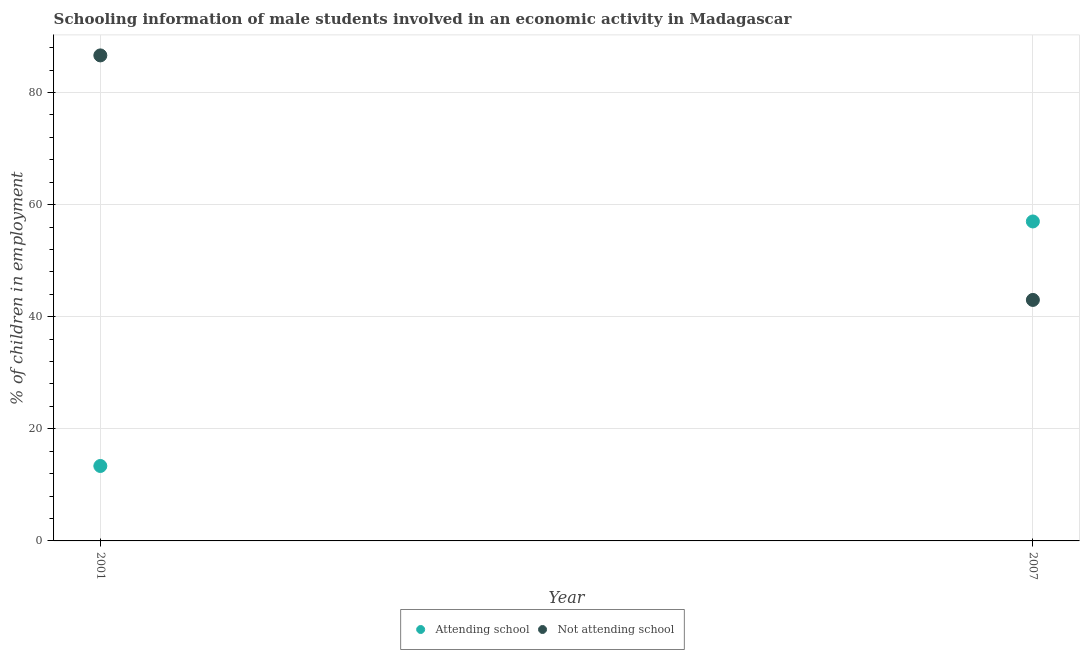What is the percentage of employed males who are not attending school in 2001?
Offer a terse response. 86.63. Across all years, what is the maximum percentage of employed males who are not attending school?
Give a very brief answer. 86.63. In which year was the percentage of employed males who are not attending school maximum?
Provide a short and direct response. 2001. In which year was the percentage of employed males who are attending school minimum?
Offer a very short reply. 2001. What is the total percentage of employed males who are attending school in the graph?
Provide a succinct answer. 70.37. What is the difference between the percentage of employed males who are not attending school in 2001 and that in 2007?
Keep it short and to the point. 43.63. What is the difference between the percentage of employed males who are not attending school in 2007 and the percentage of employed males who are attending school in 2001?
Your response must be concise. 29.63. What is the average percentage of employed males who are attending school per year?
Provide a short and direct response. 35.19. In the year 2001, what is the difference between the percentage of employed males who are attending school and percentage of employed males who are not attending school?
Your answer should be very brief. -73.26. In how many years, is the percentage of employed males who are not attending school greater than 52 %?
Keep it short and to the point. 1. What is the ratio of the percentage of employed males who are attending school in 2001 to that in 2007?
Make the answer very short. 0.23. Does the percentage of employed males who are attending school monotonically increase over the years?
Keep it short and to the point. Yes. Is the percentage of employed males who are attending school strictly less than the percentage of employed males who are not attending school over the years?
Ensure brevity in your answer.  No. How many dotlines are there?
Offer a very short reply. 2. Does the graph contain grids?
Ensure brevity in your answer.  Yes. How are the legend labels stacked?
Your answer should be very brief. Horizontal. What is the title of the graph?
Ensure brevity in your answer.  Schooling information of male students involved in an economic activity in Madagascar. What is the label or title of the X-axis?
Your answer should be very brief. Year. What is the label or title of the Y-axis?
Your answer should be very brief. % of children in employment. What is the % of children in employment in Attending school in 2001?
Provide a succinct answer. 13.37. What is the % of children in employment in Not attending school in 2001?
Keep it short and to the point. 86.63. What is the % of children in employment of Not attending school in 2007?
Ensure brevity in your answer.  43. Across all years, what is the maximum % of children in employment in Not attending school?
Your answer should be compact. 86.63. Across all years, what is the minimum % of children in employment of Attending school?
Offer a terse response. 13.37. What is the total % of children in employment in Attending school in the graph?
Provide a succinct answer. 70.37. What is the total % of children in employment of Not attending school in the graph?
Make the answer very short. 129.63. What is the difference between the % of children in employment in Attending school in 2001 and that in 2007?
Your response must be concise. -43.63. What is the difference between the % of children in employment in Not attending school in 2001 and that in 2007?
Give a very brief answer. 43.63. What is the difference between the % of children in employment in Attending school in 2001 and the % of children in employment in Not attending school in 2007?
Provide a succinct answer. -29.63. What is the average % of children in employment of Attending school per year?
Keep it short and to the point. 35.19. What is the average % of children in employment of Not attending school per year?
Your answer should be compact. 64.81. In the year 2001, what is the difference between the % of children in employment of Attending school and % of children in employment of Not attending school?
Provide a short and direct response. -73.26. What is the ratio of the % of children in employment of Attending school in 2001 to that in 2007?
Provide a short and direct response. 0.23. What is the ratio of the % of children in employment in Not attending school in 2001 to that in 2007?
Give a very brief answer. 2.01. What is the difference between the highest and the second highest % of children in employment in Attending school?
Your answer should be very brief. 43.63. What is the difference between the highest and the second highest % of children in employment of Not attending school?
Make the answer very short. 43.63. What is the difference between the highest and the lowest % of children in employment of Attending school?
Keep it short and to the point. 43.63. What is the difference between the highest and the lowest % of children in employment in Not attending school?
Keep it short and to the point. 43.63. 